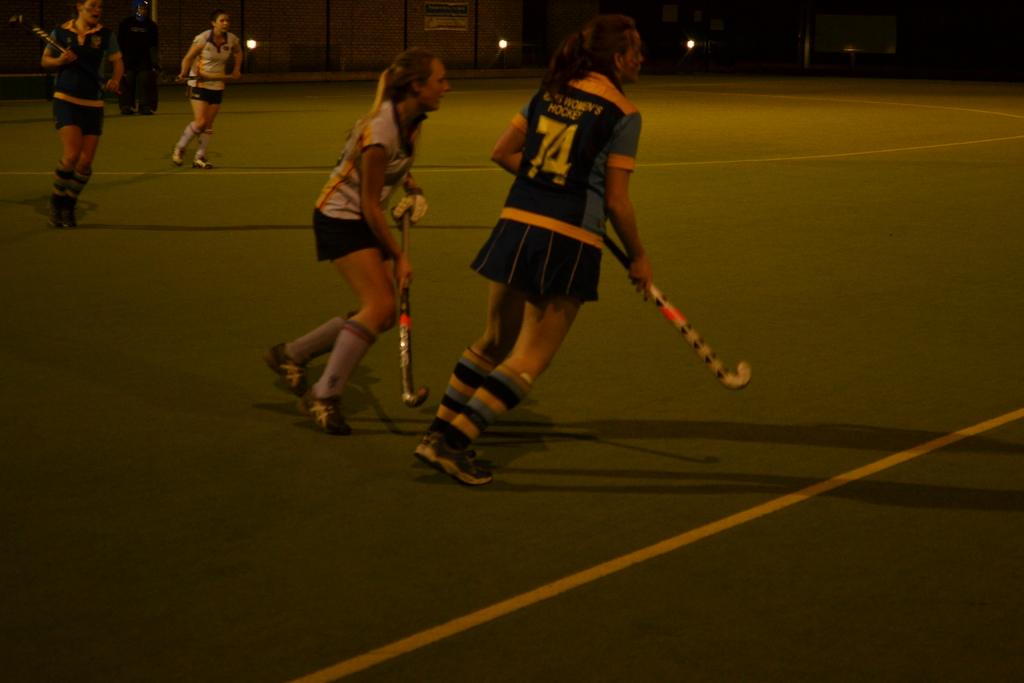Who is playing the sport in the image? There are women in the image playing hockey. Where is the hockey game taking place? The game is taking place on a ground. What is the purpose of the mesh visible at the top of the image? The mesh is likely a goal or net used in the game of hockey. How many tickets are available for the space exploration event in the image? There is no space exploration event or tickets present in the image; it features women playing hockey on a ground. 